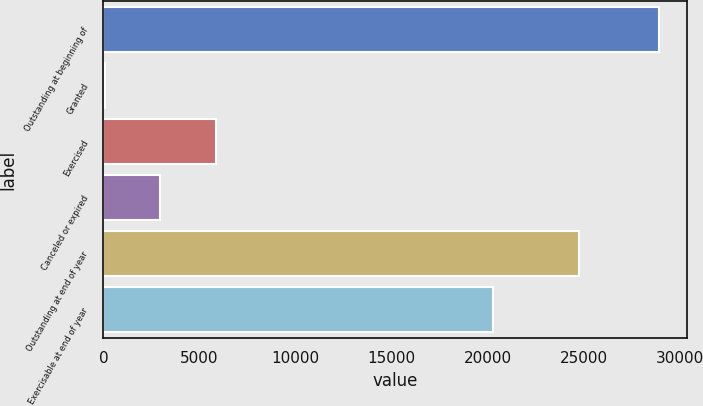Convert chart. <chart><loc_0><loc_0><loc_500><loc_500><bar_chart><fcel>Outstanding at beginning of<fcel>Granted<fcel>Exercised<fcel>Canceled or expired<fcel>Outstanding at end of year<fcel>Exercisable at end of year<nl><fcel>28918<fcel>74<fcel>5842.8<fcel>2958.4<fcel>24727<fcel>20290<nl></chart> 